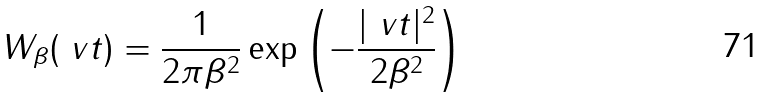<formula> <loc_0><loc_0><loc_500><loc_500>W _ { \beta } ( \ v t ) = \frac { 1 } { 2 \pi \beta ^ { 2 } } \exp \left ( - \frac { | \ v t | ^ { 2 } } { 2 \beta ^ { 2 } } \right )</formula> 